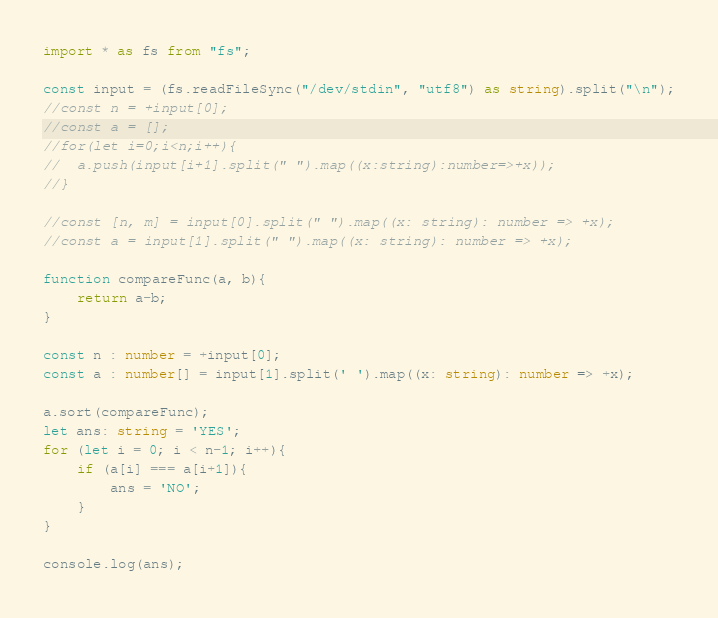<code> <loc_0><loc_0><loc_500><loc_500><_TypeScript_>import * as fs from "fs";

const input = (fs.readFileSync("/dev/stdin", "utf8") as string).split("\n");
//const n = +input[0];
//const a = [];
//for(let i=0;i<n;i++){
//	a.push(input[i+1].split(" ").map((x:string):number=>+x));
//}

//const [n, m] = input[0].split(" ").map((x: string): number => +x);
//const a = input[1].split(" ").map((x: string): number => +x);

function compareFunc(a, b){
    return a-b;
}

const n : number = +input[0];
const a : number[] = input[1].split(' ').map((x: string): number => +x);

a.sort(compareFunc);
let ans: string = 'YES';
for (let i = 0; i < n-1; i++){
    if (a[i] === a[i+1]){
        ans = 'NO';
    }
}

console.log(ans);</code> 